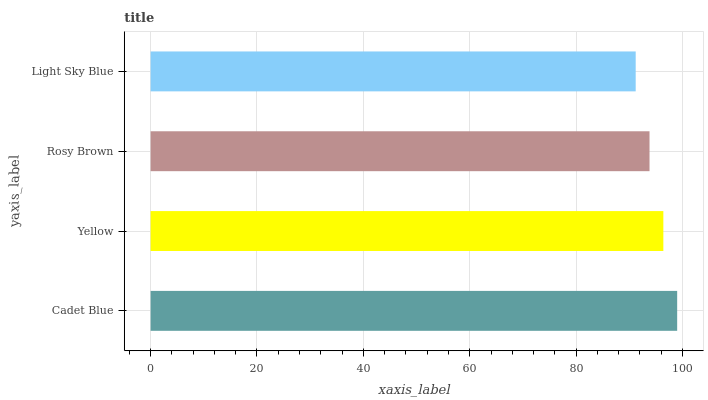Is Light Sky Blue the minimum?
Answer yes or no. Yes. Is Cadet Blue the maximum?
Answer yes or no. Yes. Is Yellow the minimum?
Answer yes or no. No. Is Yellow the maximum?
Answer yes or no. No. Is Cadet Blue greater than Yellow?
Answer yes or no. Yes. Is Yellow less than Cadet Blue?
Answer yes or no. Yes. Is Yellow greater than Cadet Blue?
Answer yes or no. No. Is Cadet Blue less than Yellow?
Answer yes or no. No. Is Yellow the high median?
Answer yes or no. Yes. Is Rosy Brown the low median?
Answer yes or no. Yes. Is Cadet Blue the high median?
Answer yes or no. No. Is Cadet Blue the low median?
Answer yes or no. No. 